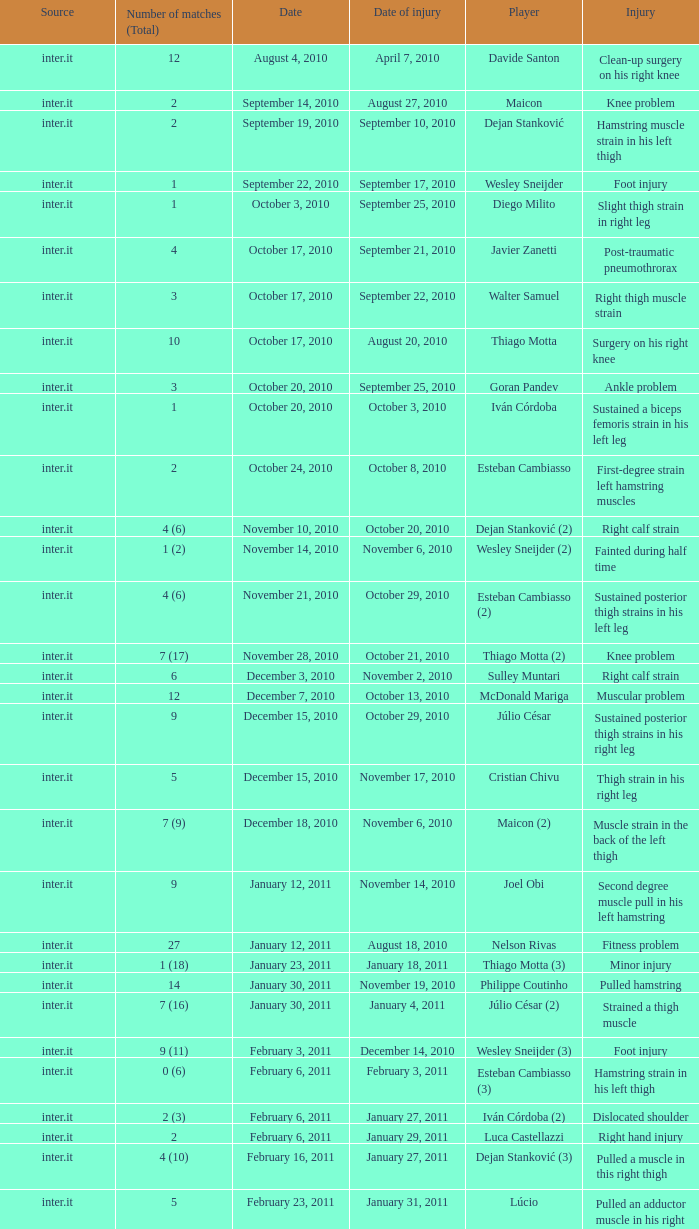What is the date of injury for player Wesley sneijder (2)? November 6, 2010. 